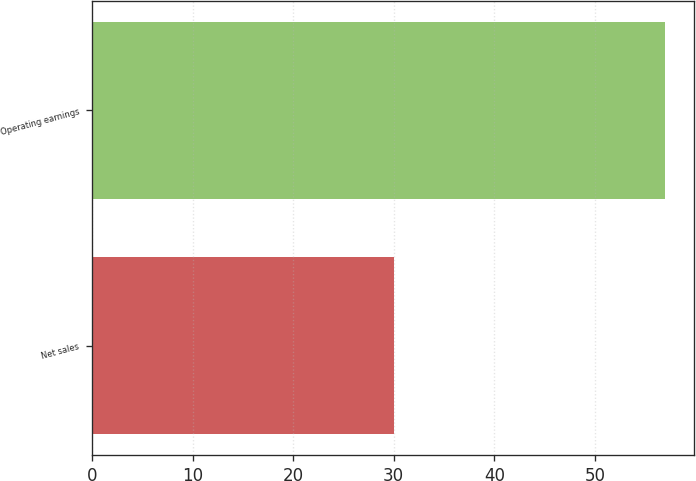Convert chart to OTSL. <chart><loc_0><loc_0><loc_500><loc_500><bar_chart><fcel>Net sales<fcel>Operating earnings<nl><fcel>30<fcel>57<nl></chart> 